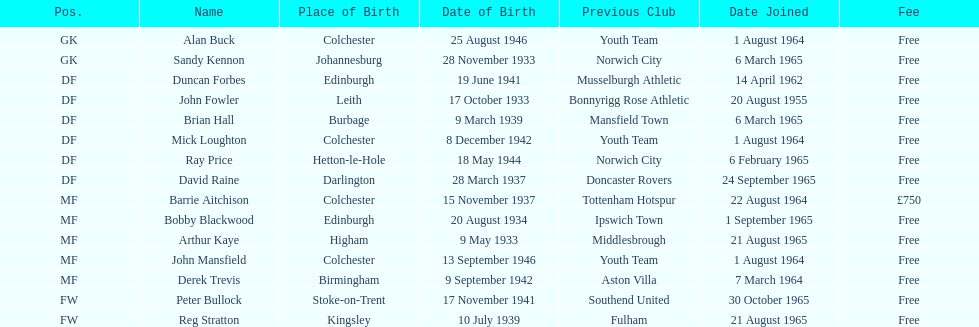Which player is the oldest? Arthur Kaye. 